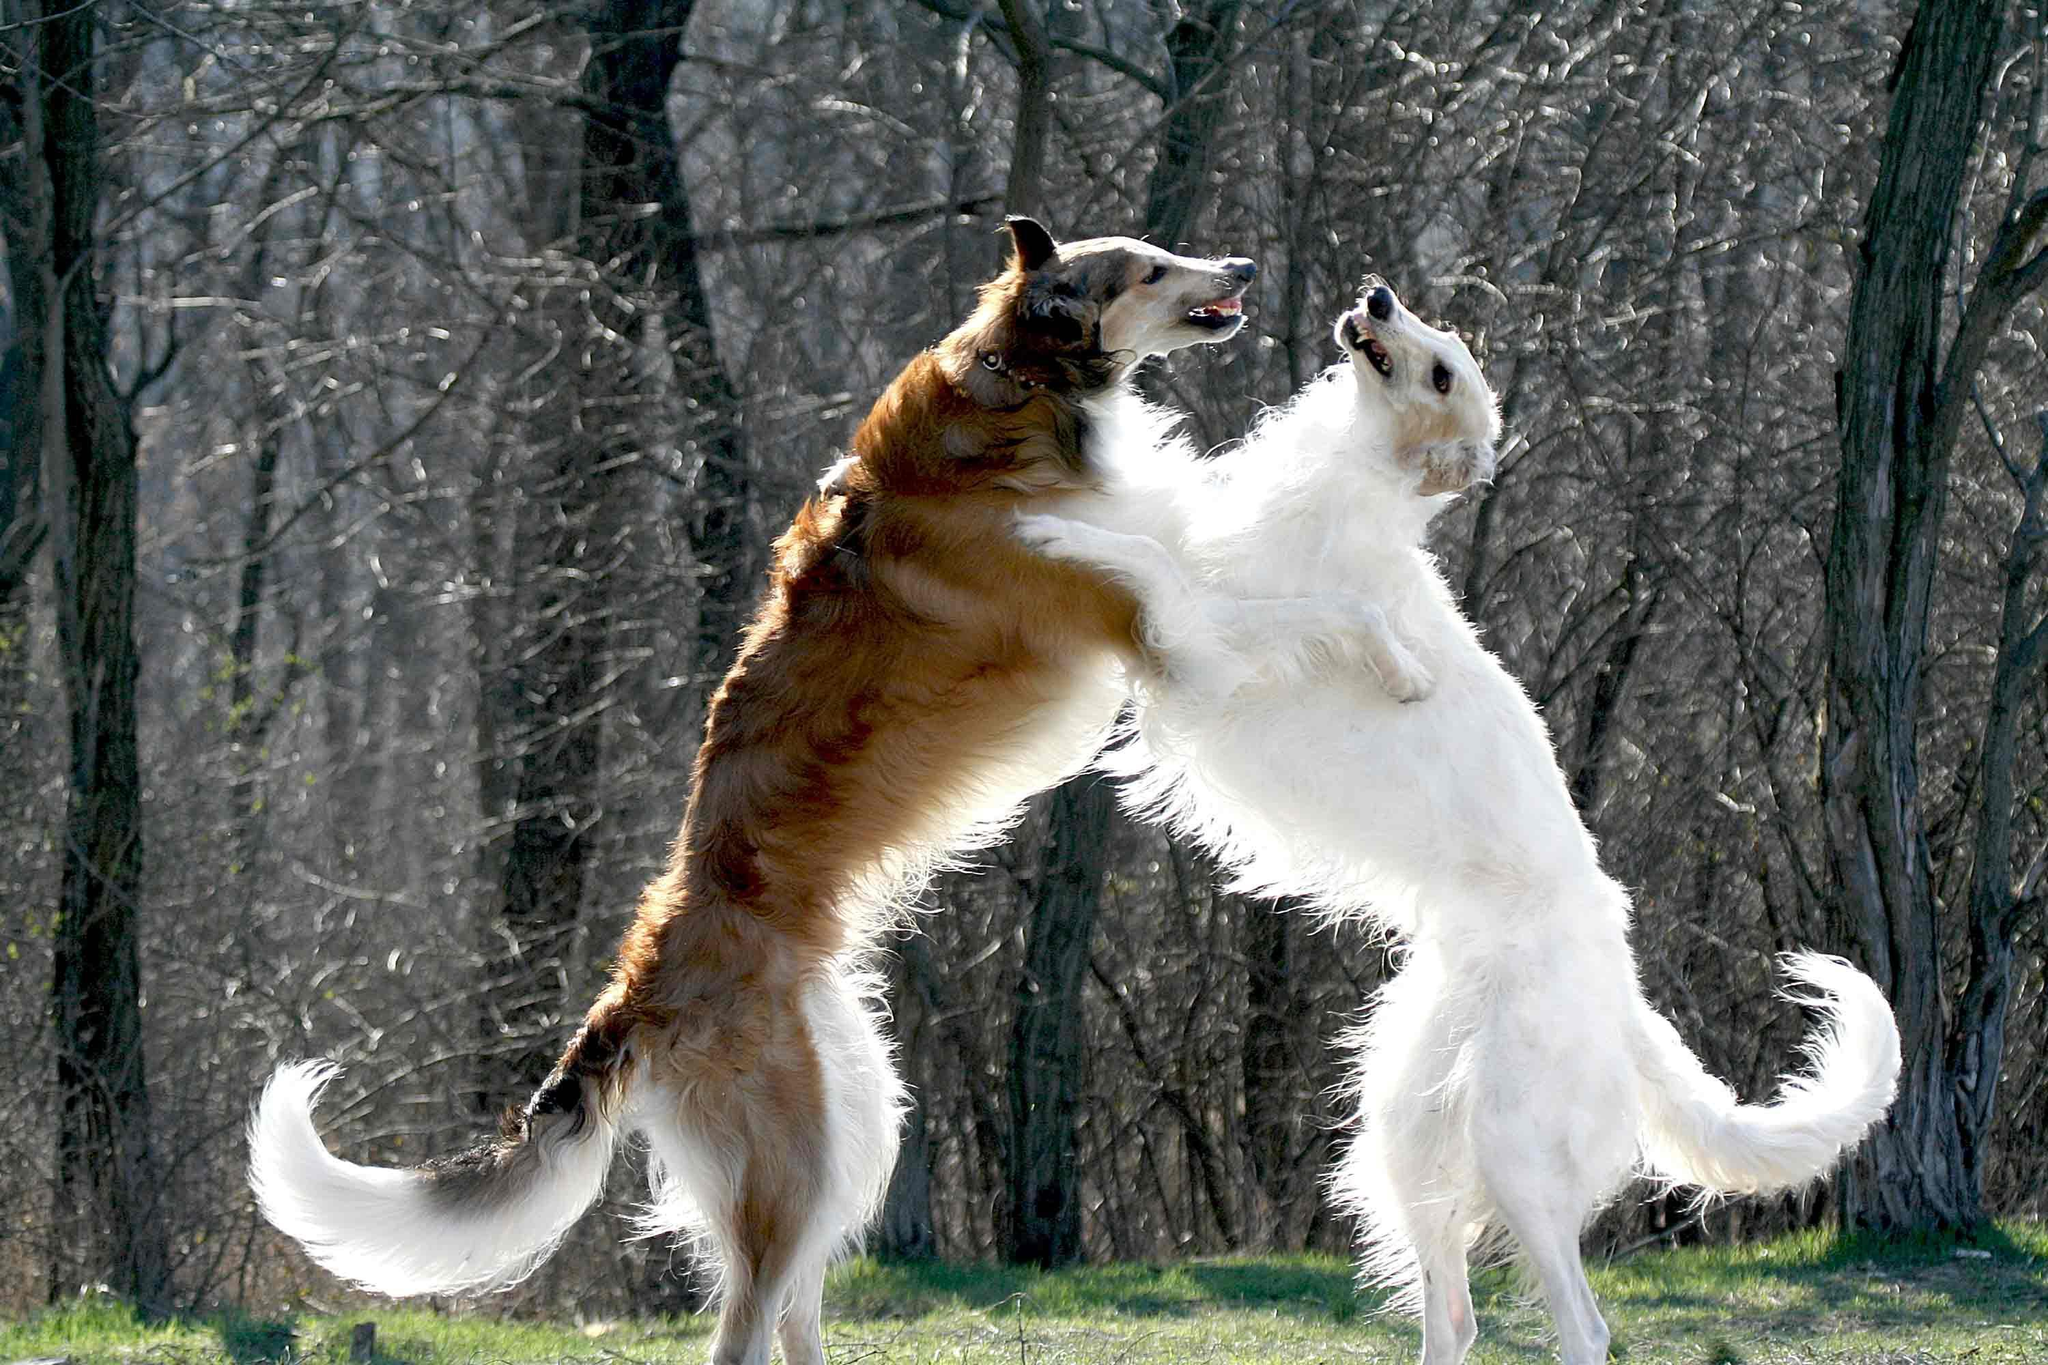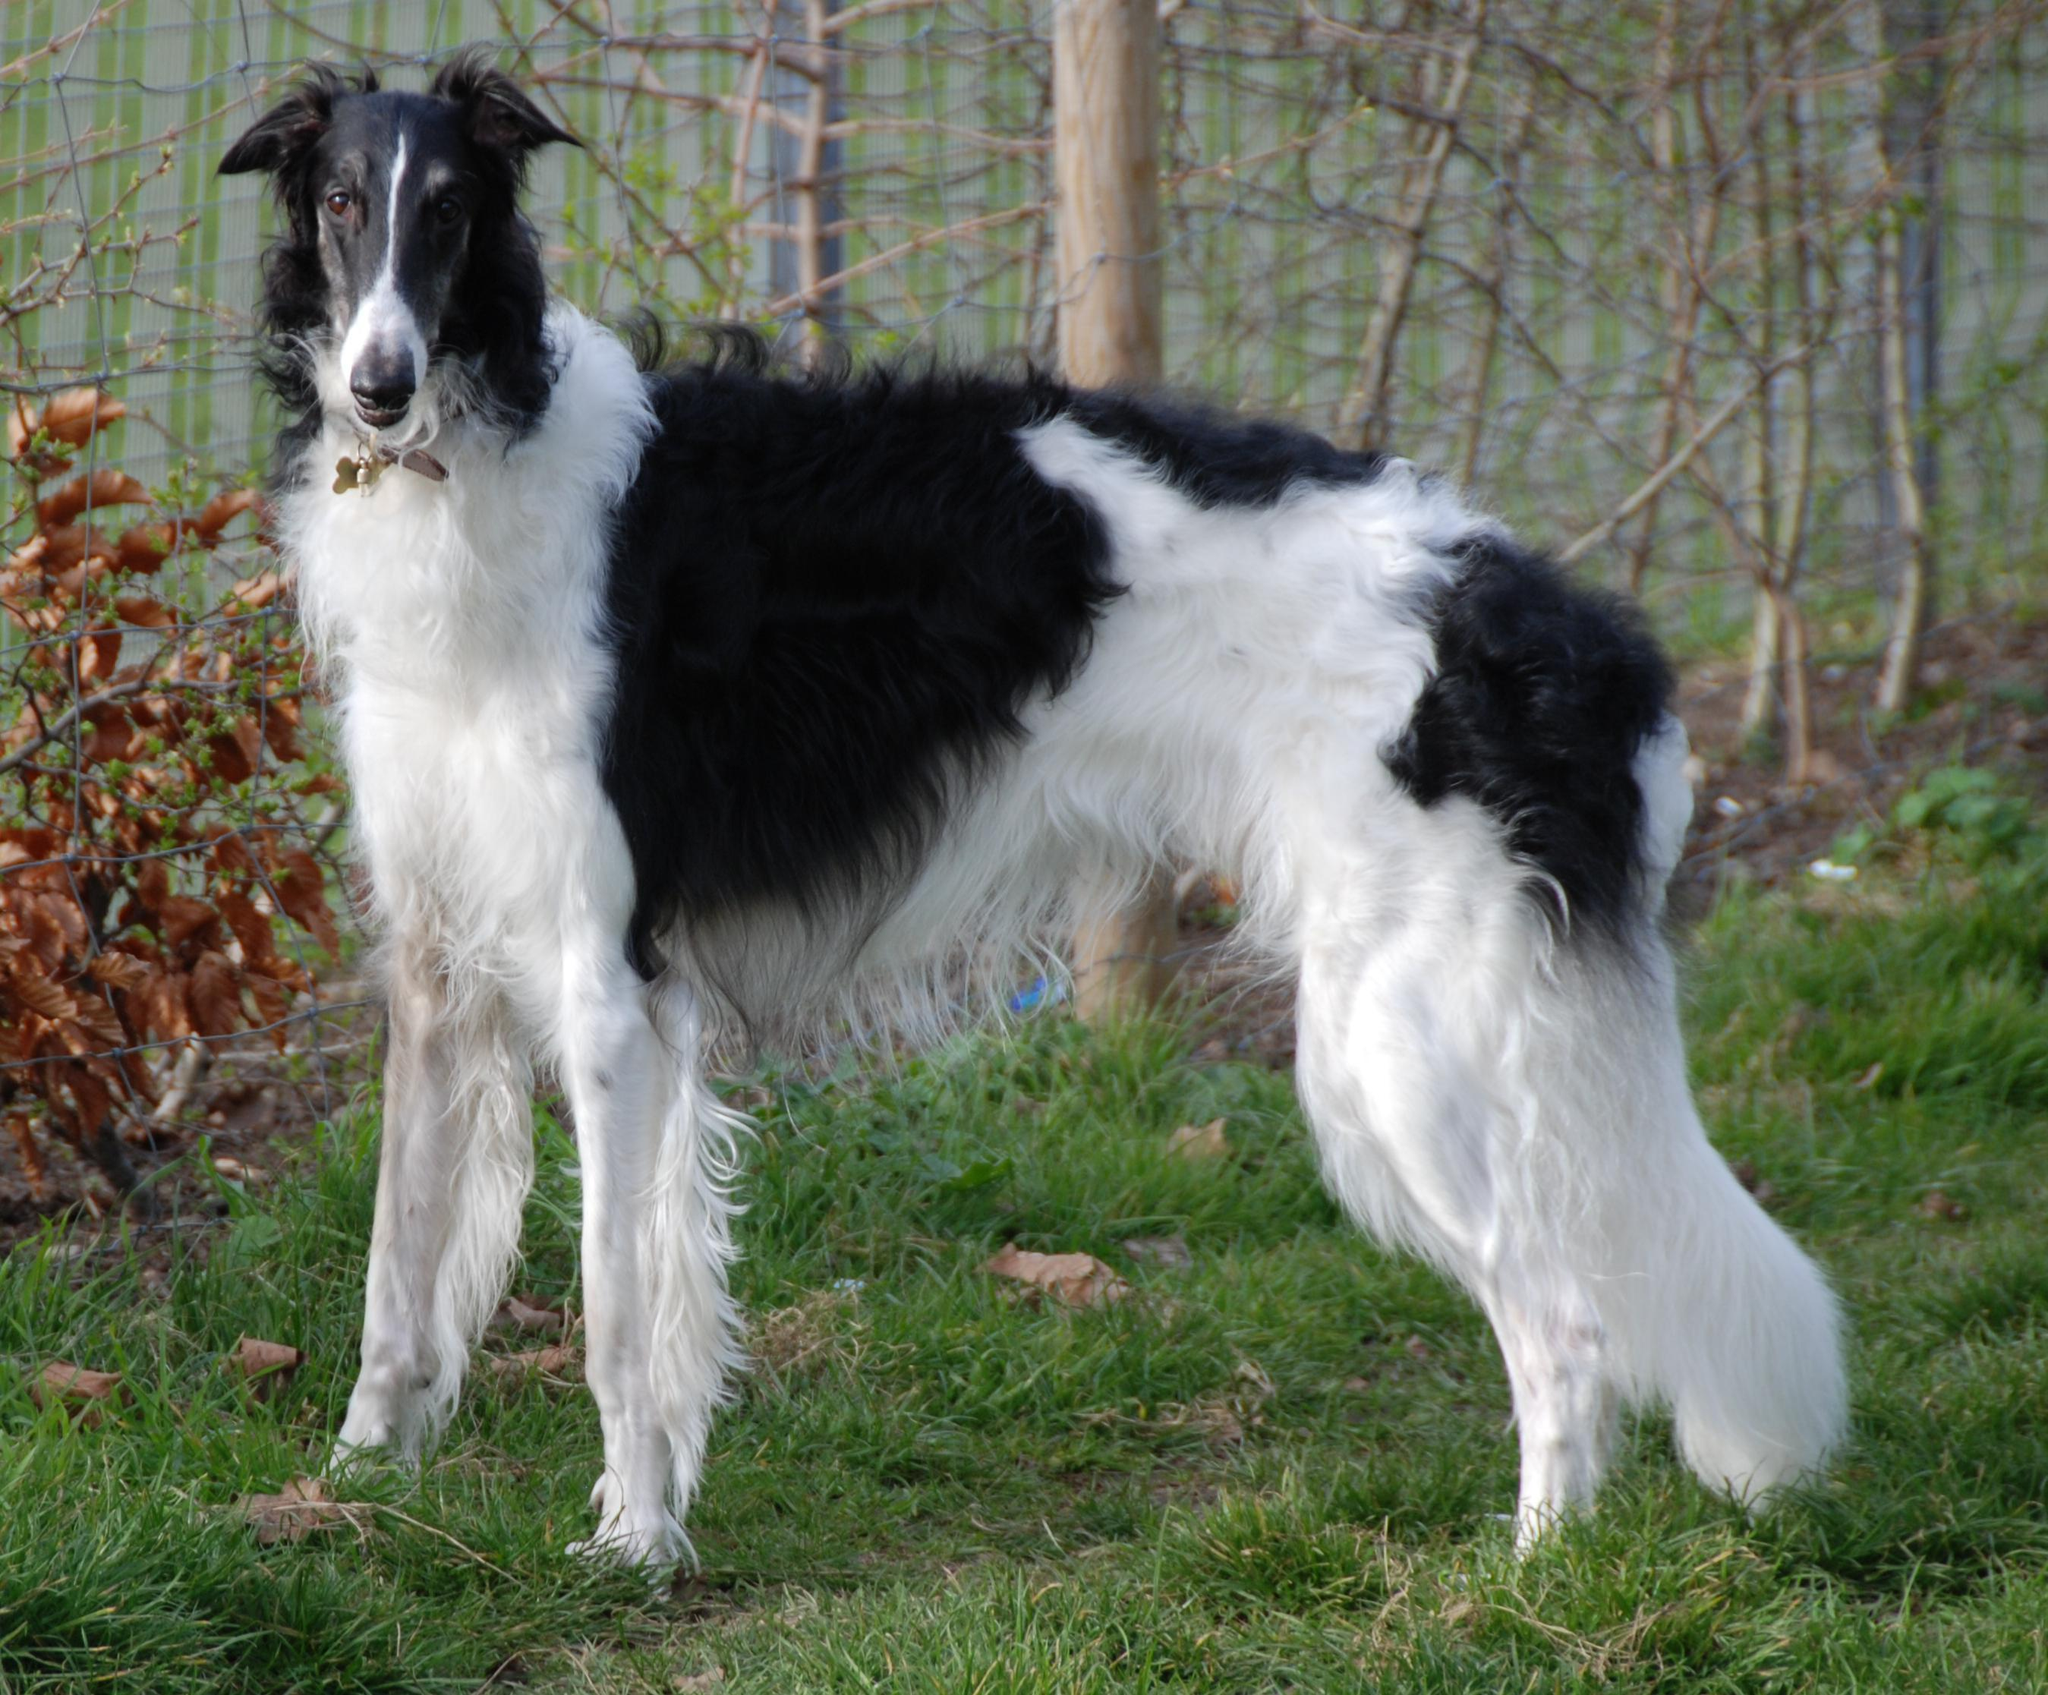The first image is the image on the left, the second image is the image on the right. For the images shown, is this caption "There are more than two dogs present." true? Answer yes or no. Yes. The first image is the image on the left, the second image is the image on the right. Examine the images to the left and right. Is the description "There is only one dog in both pictures" accurate? Answer yes or no. No. 